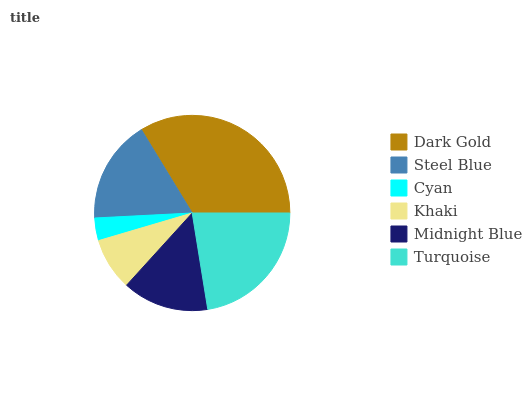Is Cyan the minimum?
Answer yes or no. Yes. Is Dark Gold the maximum?
Answer yes or no. Yes. Is Steel Blue the minimum?
Answer yes or no. No. Is Steel Blue the maximum?
Answer yes or no. No. Is Dark Gold greater than Steel Blue?
Answer yes or no. Yes. Is Steel Blue less than Dark Gold?
Answer yes or no. Yes. Is Steel Blue greater than Dark Gold?
Answer yes or no. No. Is Dark Gold less than Steel Blue?
Answer yes or no. No. Is Steel Blue the high median?
Answer yes or no. Yes. Is Midnight Blue the low median?
Answer yes or no. Yes. Is Dark Gold the high median?
Answer yes or no. No. Is Dark Gold the low median?
Answer yes or no. No. 